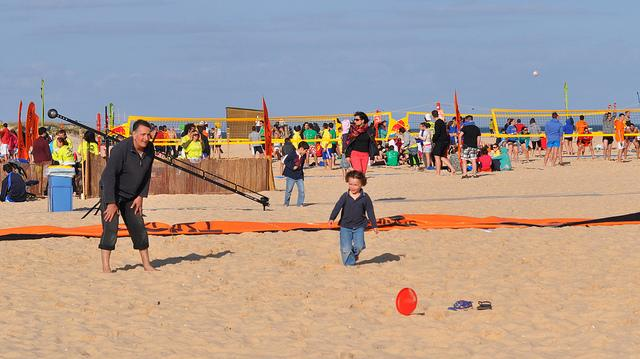What do they want to prevent the ball from touching?

Choices:
A) grass
B) sand
C) people
D) net sand 